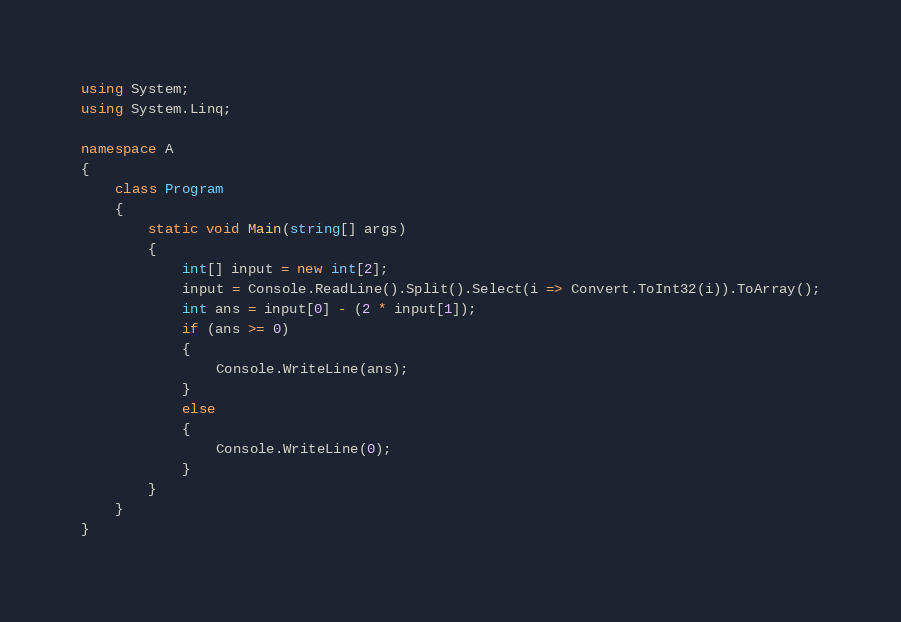<code> <loc_0><loc_0><loc_500><loc_500><_C#_>using System;
using System.Linq;

namespace A
{
    class Program
    {
        static void Main(string[] args)
        {
            int[] input = new int[2];
            input = Console.ReadLine().Split().Select(i => Convert.ToInt32(i)).ToArray();
            int ans = input[0] - (2 * input[1]);
            if (ans >= 0)
            {
                Console.WriteLine(ans);
            }
            else
            {
                Console.WriteLine(0);
            }
        }
    }
}
</code> 